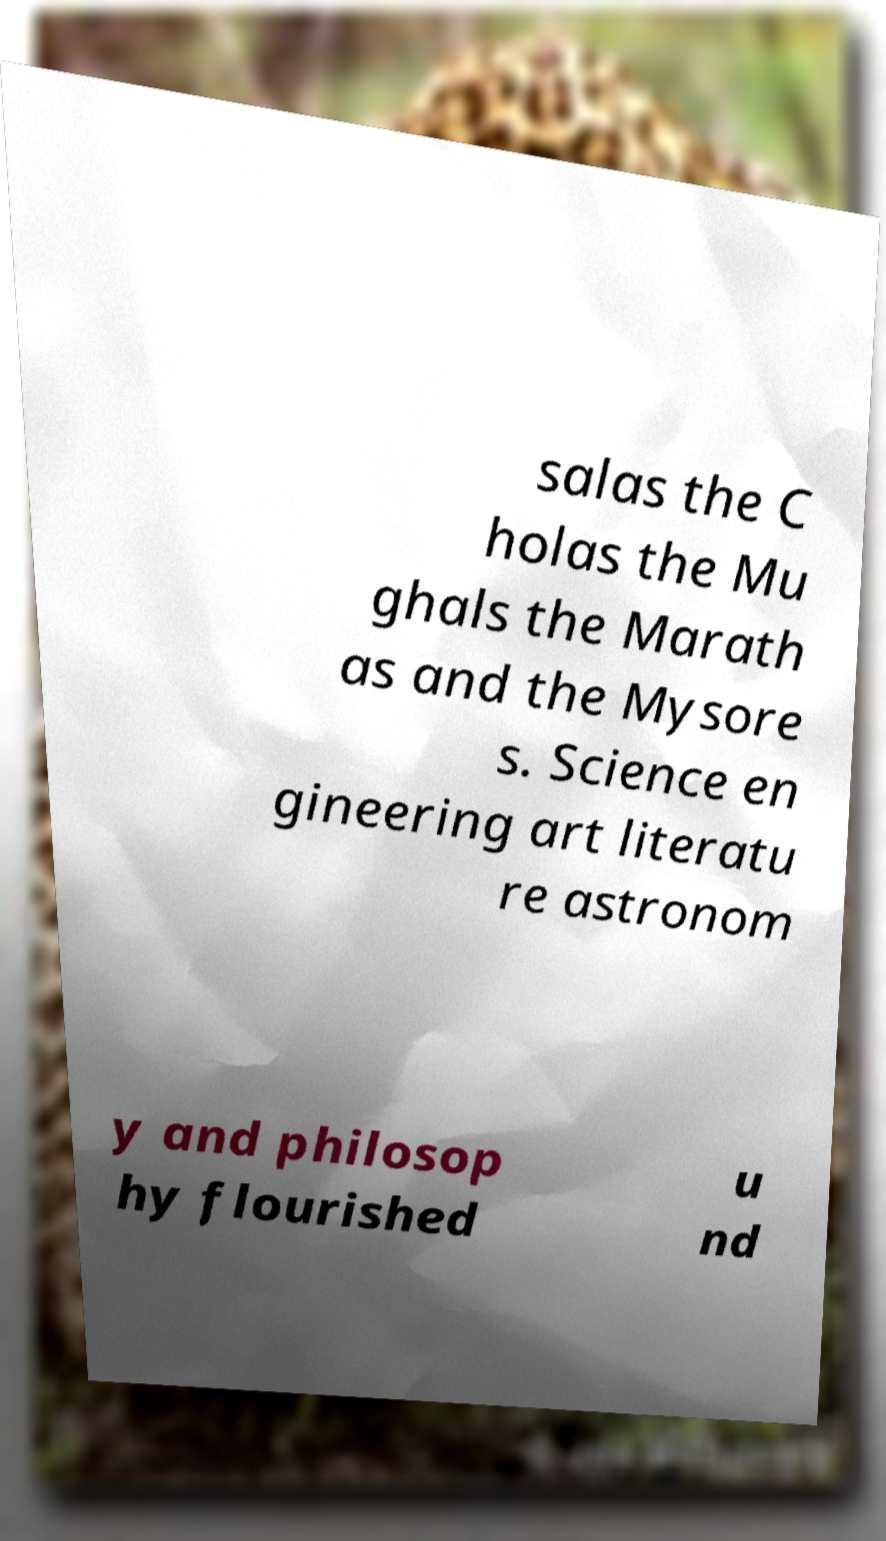Please read and relay the text visible in this image. What does it say? salas the C holas the Mu ghals the Marath as and the Mysore s. Science en gineering art literatu re astronom y and philosop hy flourished u nd 